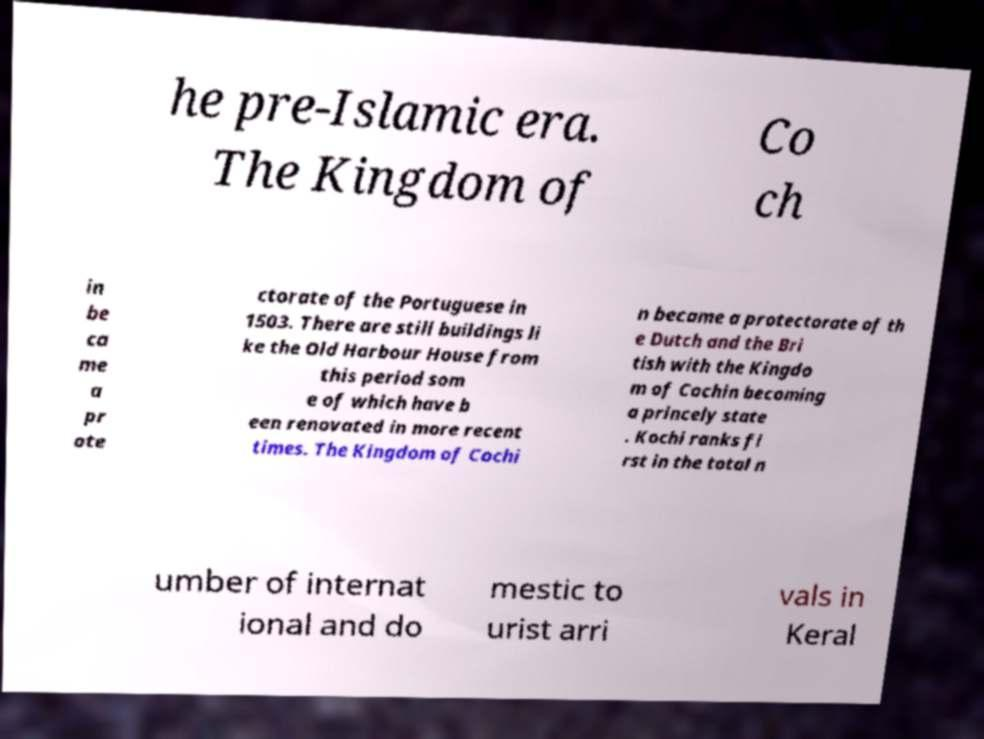Can you accurately transcribe the text from the provided image for me? he pre-Islamic era. The Kingdom of Co ch in be ca me a pr ote ctorate of the Portuguese in 1503. There are still buildings li ke the Old Harbour House from this period som e of which have b een renovated in more recent times. The Kingdom of Cochi n became a protectorate of th e Dutch and the Bri tish with the Kingdo m of Cochin becoming a princely state . Kochi ranks fi rst in the total n umber of internat ional and do mestic to urist arri vals in Keral 